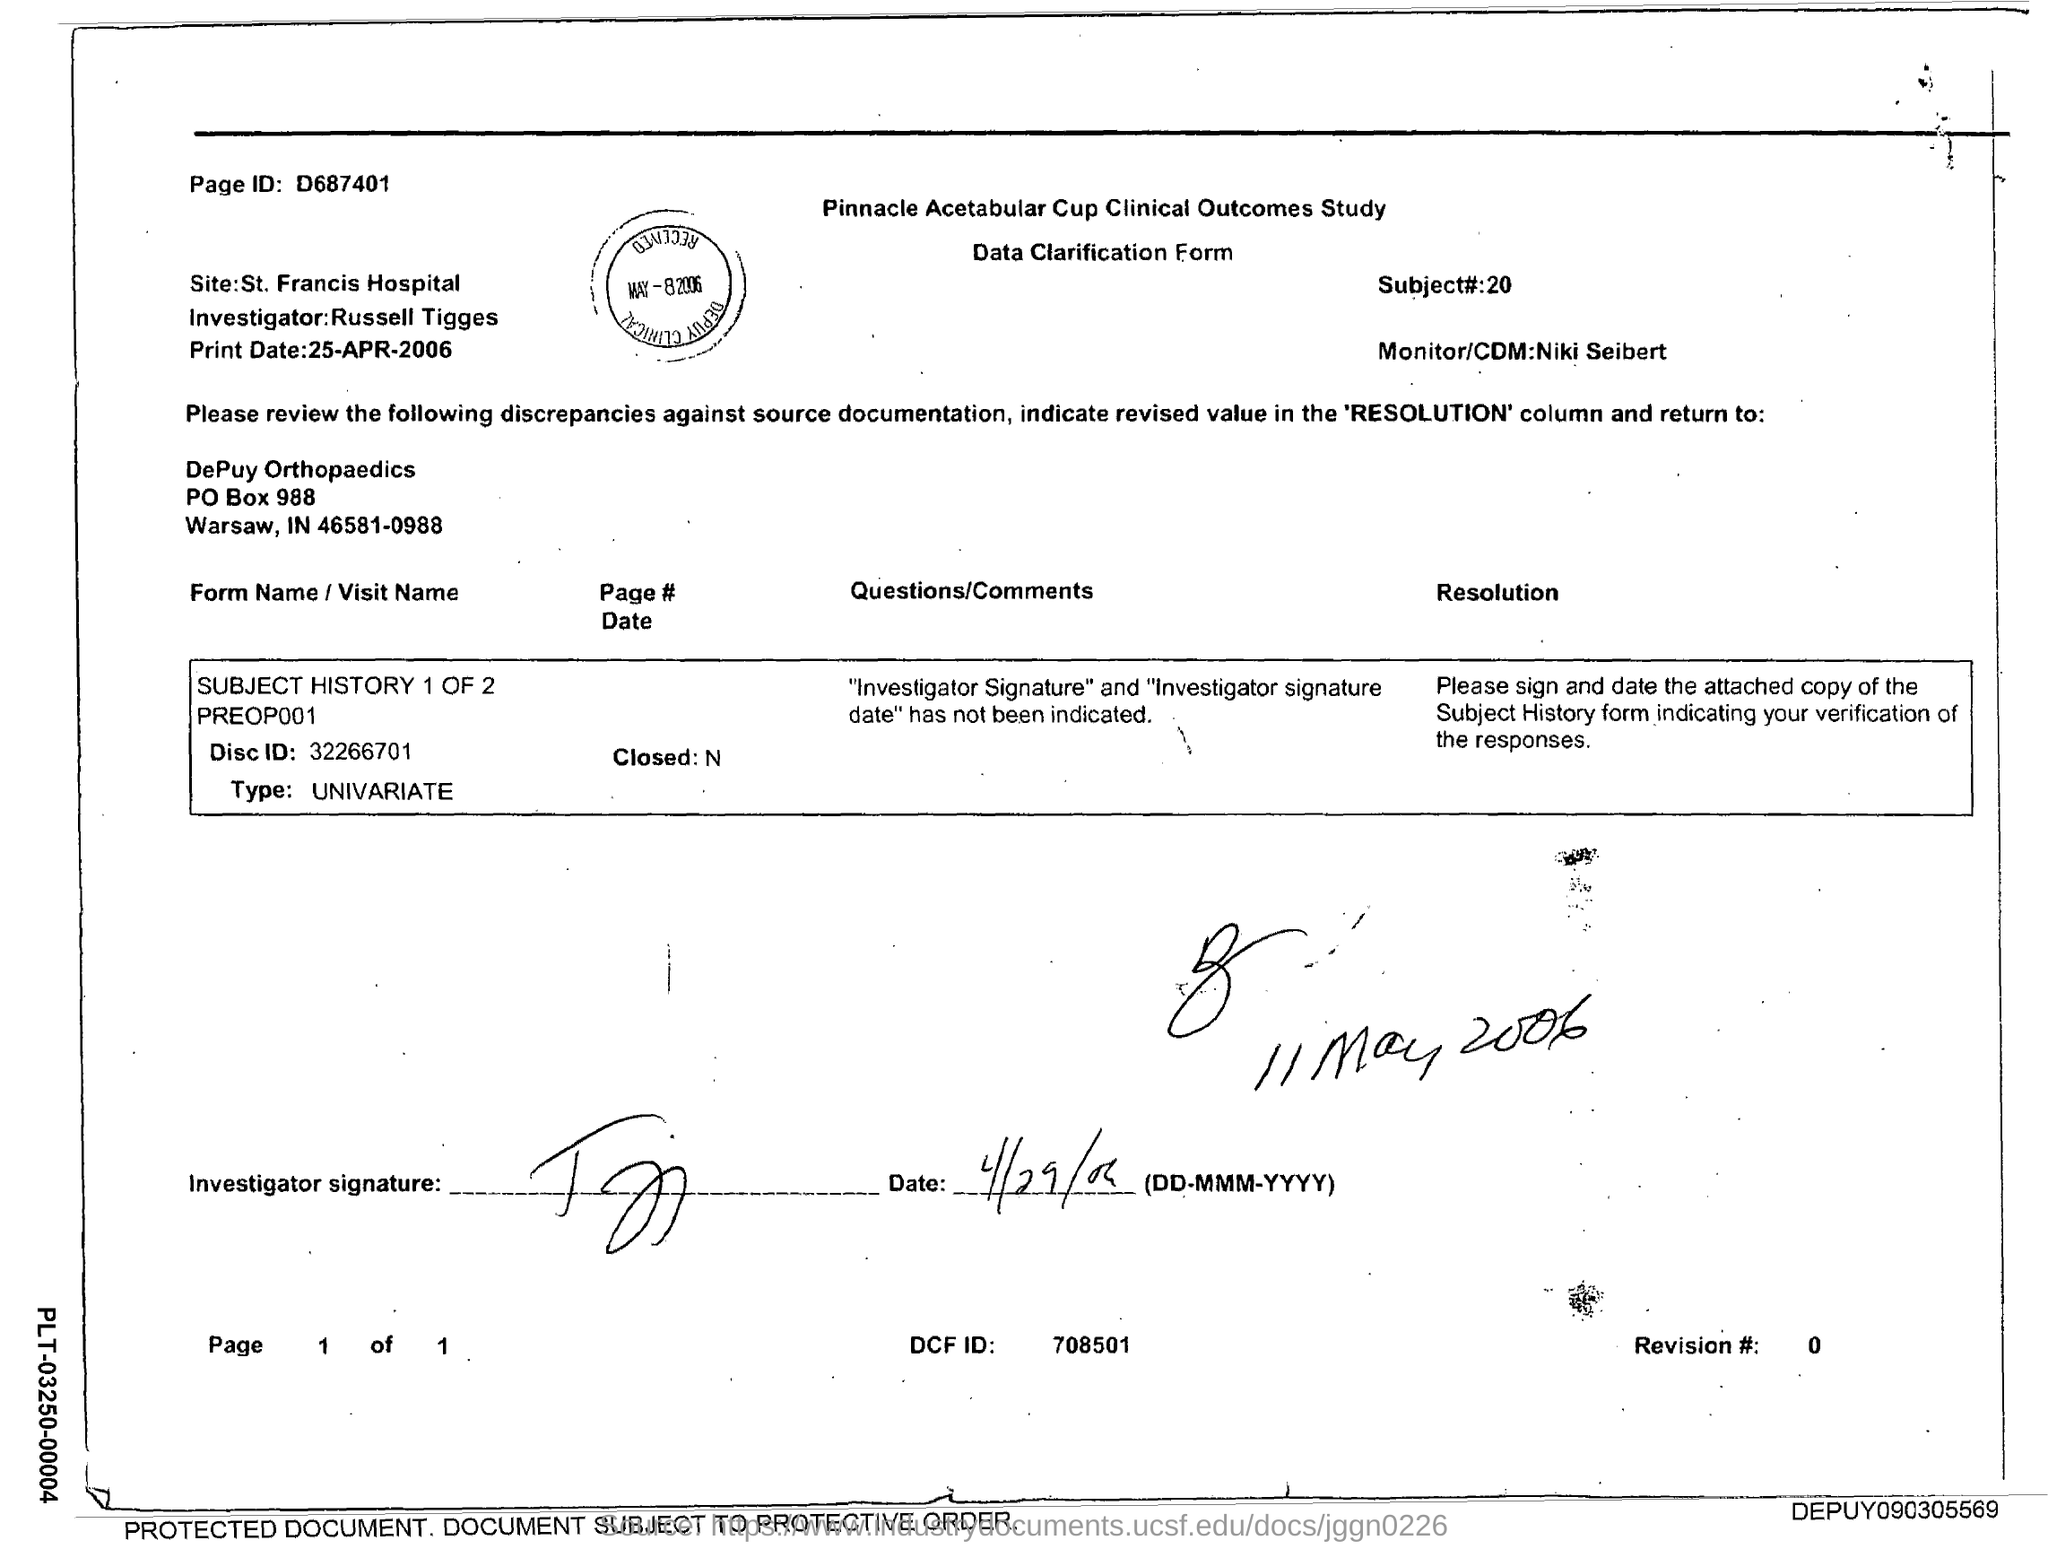What is the page id?
Keep it short and to the point. D687401. What is the Subject# number?
Make the answer very short. 20. What is the name of the Investigator?
Ensure brevity in your answer.  Russell Tigges. What is the Revision # number?
Ensure brevity in your answer.  0. 